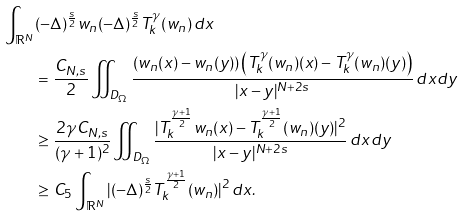<formula> <loc_0><loc_0><loc_500><loc_500>\int _ { \mathbb { R } ^ { N } } & ( - \Delta ) ^ { \frac { s } { 2 } } w _ { n } ( - \Delta ) ^ { \frac { s } { 2 } } T _ { k } ^ { \gamma } ( w _ { n } ) \, d x \\ & = \frac { C _ { N , s } } { 2 } \iint _ { D _ { \Omega } } \frac { \left ( w _ { n } ( x ) - w _ { n } ( y ) \right ) \left ( T _ { k } ^ { \gamma } ( w _ { n } ) ( x ) - T _ { k } ^ { \gamma } ( w _ { n } ) ( y ) \right ) } { | x - y | ^ { N + 2 s } } \, d x d y \\ & \geq \frac { 2 \gamma C _ { N , s } } { ( \gamma + 1 ) ^ { 2 } } \iint _ { D _ { \Omega } } \frac { | T _ { k } ^ { \frac { \gamma + 1 } { 2 } } w _ { n } ( x ) - T _ { k } ^ { \frac { \gamma + 1 } { 2 } } ( w _ { n } ) ( y ) | ^ { 2 } } { | x - y | ^ { N + 2 s } } \, d x d y \\ & \geq C _ { 5 } \int _ { \mathbb { R } ^ { N } } | ( - \Delta ) ^ { \frac { s } { 2 } } T _ { k } ^ { \frac { \gamma + 1 } { 2 } } ( w _ { n } ) | ^ { 2 } \, d x .</formula> 